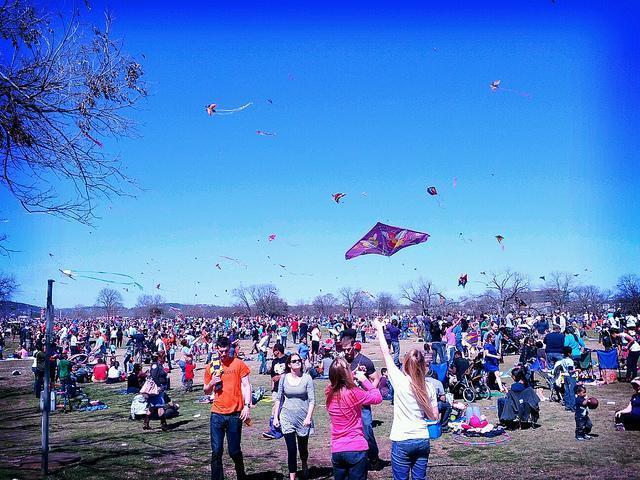How many people are in the picture?
Give a very brief answer. 5. How many slices does this pizza have?
Give a very brief answer. 0. 